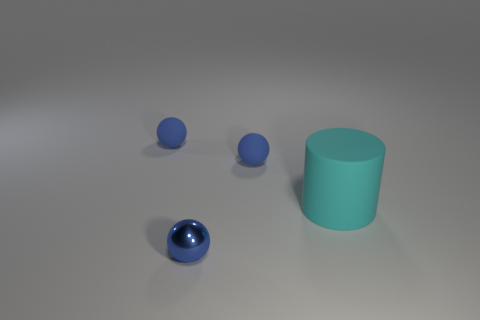There is a blue metallic sphere that is in front of the matte ball that is to the left of the metal sphere; are there any tiny blue rubber things that are behind it?
Keep it short and to the point. Yes. How many other objects are there of the same color as the cylinder?
Your answer should be very brief. 0. What number of things are both behind the small blue metal ball and left of the big cyan object?
Your response must be concise. 2. What is the shape of the small metallic thing?
Provide a short and direct response. Sphere. How many other objects are there of the same material as the cyan thing?
Ensure brevity in your answer.  2. The thing that is in front of the large cyan matte cylinder right of the small ball that is in front of the cyan rubber thing is what color?
Your answer should be compact. Blue. How many things are tiny objects behind the blue metallic thing or big objects?
Your response must be concise. 3. Are any green matte spheres visible?
Provide a short and direct response. No. What is the material of the blue thing that is on the left side of the shiny ball?
Ensure brevity in your answer.  Rubber. How many small things are matte cylinders or yellow cylinders?
Your answer should be compact. 0. 